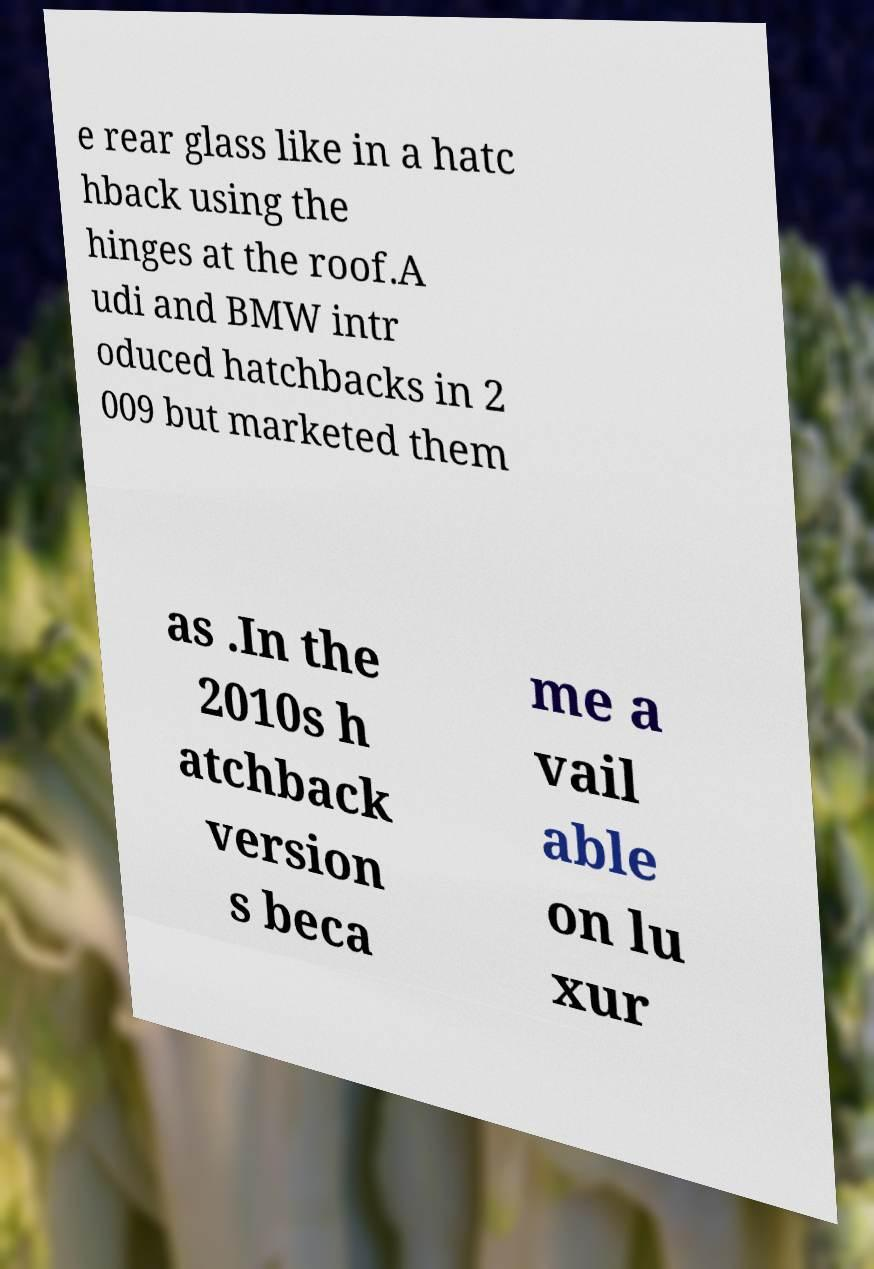Could you assist in decoding the text presented in this image and type it out clearly? e rear glass like in a hatc hback using the hinges at the roof.A udi and BMW intr oduced hatchbacks in 2 009 but marketed them as .In the 2010s h atchback version s beca me a vail able on lu xur 